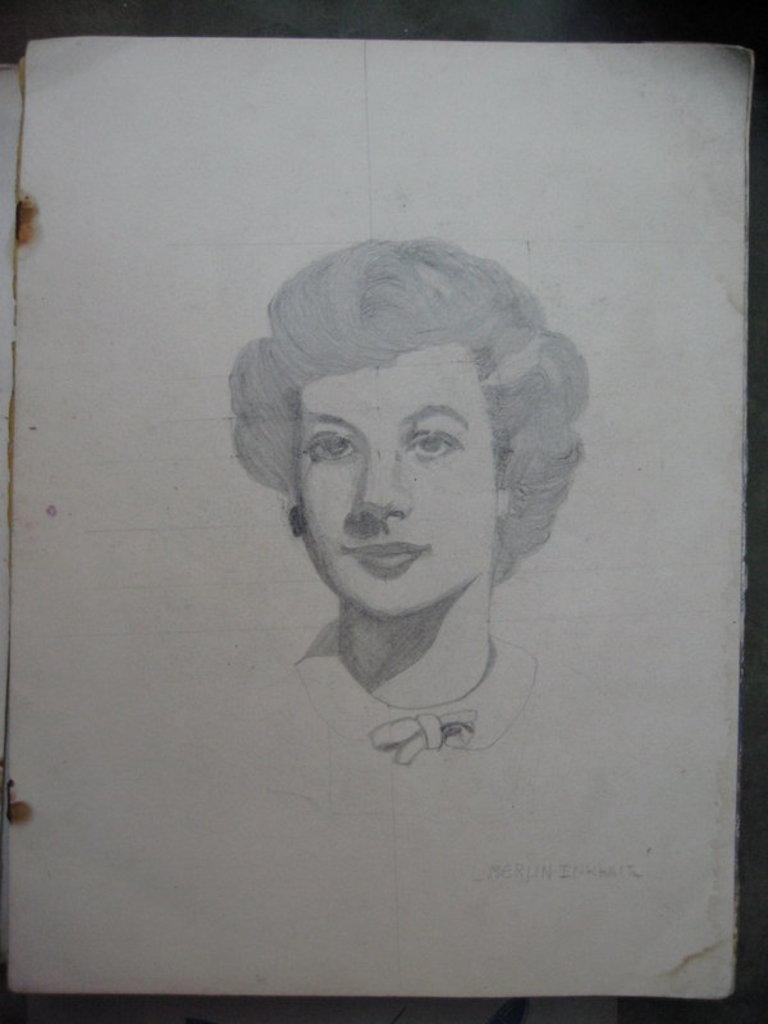What is depicted in the image? There is a drawing of a woman in the image. What is the drawing on? The drawing is on a paper. Are there any words or letters in the image? Yes, there is written text in the image. How does the beggar interact with the drawing in the image? There is no beggar present in the image; it only contains a drawing of a woman and written text. 